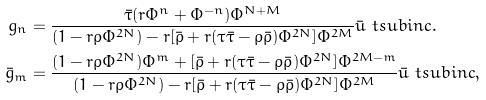Convert formula to latex. <formula><loc_0><loc_0><loc_500><loc_500>g _ { n } & = \frac { \bar { \tau } ( r \Phi ^ { n } + \Phi ^ { - n } ) \Phi ^ { N + M } } { ( 1 - r \rho \Phi ^ { 2 N } ) - r [ \bar { \rho } + r ( \tau \bar { \tau } - \rho \bar { \rho } ) \Phi ^ { 2 N } ] \Phi ^ { 2 M } } \bar { u } \ t s u b { i n c } . \\ \bar { g } _ { m } & = \frac { ( 1 - r \rho \Phi ^ { 2 N } ) \Phi ^ { m } + [ \bar { \rho } + r ( \tau \bar { \tau } - \rho \bar { \rho } ) \Phi ^ { 2 N } ] \Phi ^ { 2 M - m } } { ( 1 - r \rho \Phi ^ { 2 N } ) - r [ \bar { \rho } + r ( \tau \bar { \tau } - \rho \bar { \rho } ) \Phi ^ { 2 N } ] \Phi ^ { 2 M } } \bar { u } \ t s u b { i n c } ,</formula> 